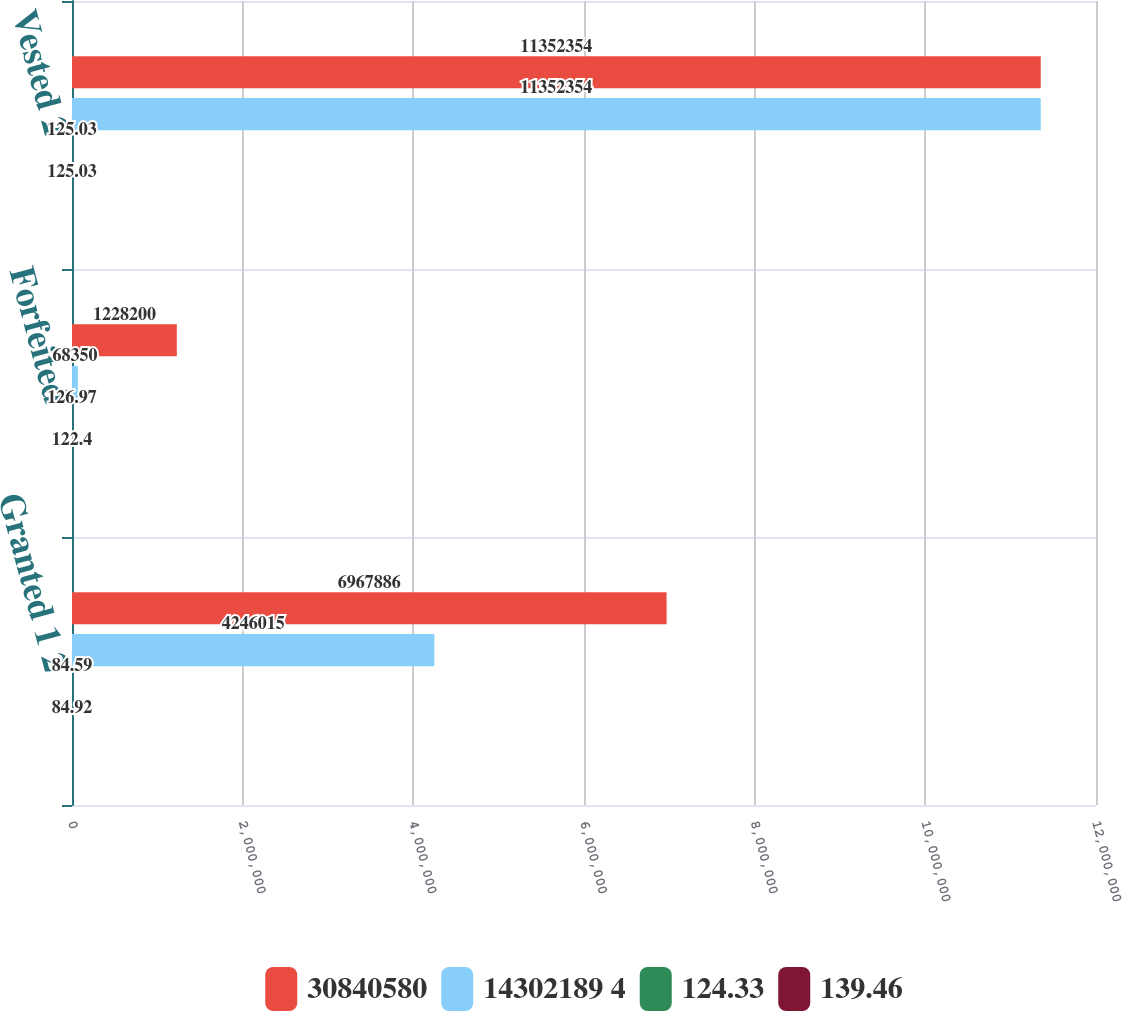<chart> <loc_0><loc_0><loc_500><loc_500><stacked_bar_chart><ecel><fcel>Granted 1 2<fcel>Forfeited<fcel>Vested 2<nl><fcel>30840580<fcel>6.96789e+06<fcel>1.2282e+06<fcel>1.13524e+07<nl><fcel>14302189 4<fcel>4.24602e+06<fcel>68350<fcel>1.13524e+07<nl><fcel>124.33<fcel>84.59<fcel>126.97<fcel>125.03<nl><fcel>139.46<fcel>84.92<fcel>122.4<fcel>125.03<nl></chart> 